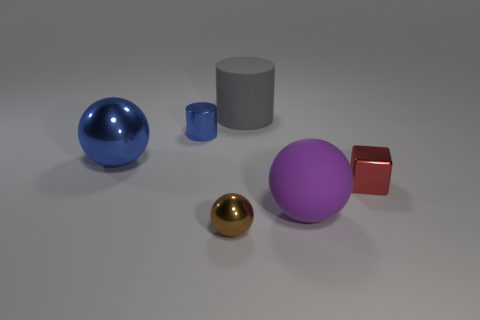Add 1 metallic blocks. How many objects exist? 7 Subtract all cylinders. How many objects are left? 4 Subtract 0 green spheres. How many objects are left? 6 Subtract all tiny cyan matte objects. Subtract all purple balls. How many objects are left? 5 Add 2 large purple matte spheres. How many large purple matte spheres are left? 3 Add 2 small metal spheres. How many small metal spheres exist? 3 